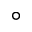<formula> <loc_0><loc_0><loc_500><loc_500>^ { \circ }</formula> 